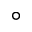<formula> <loc_0><loc_0><loc_500><loc_500>^ { \circ }</formula> 